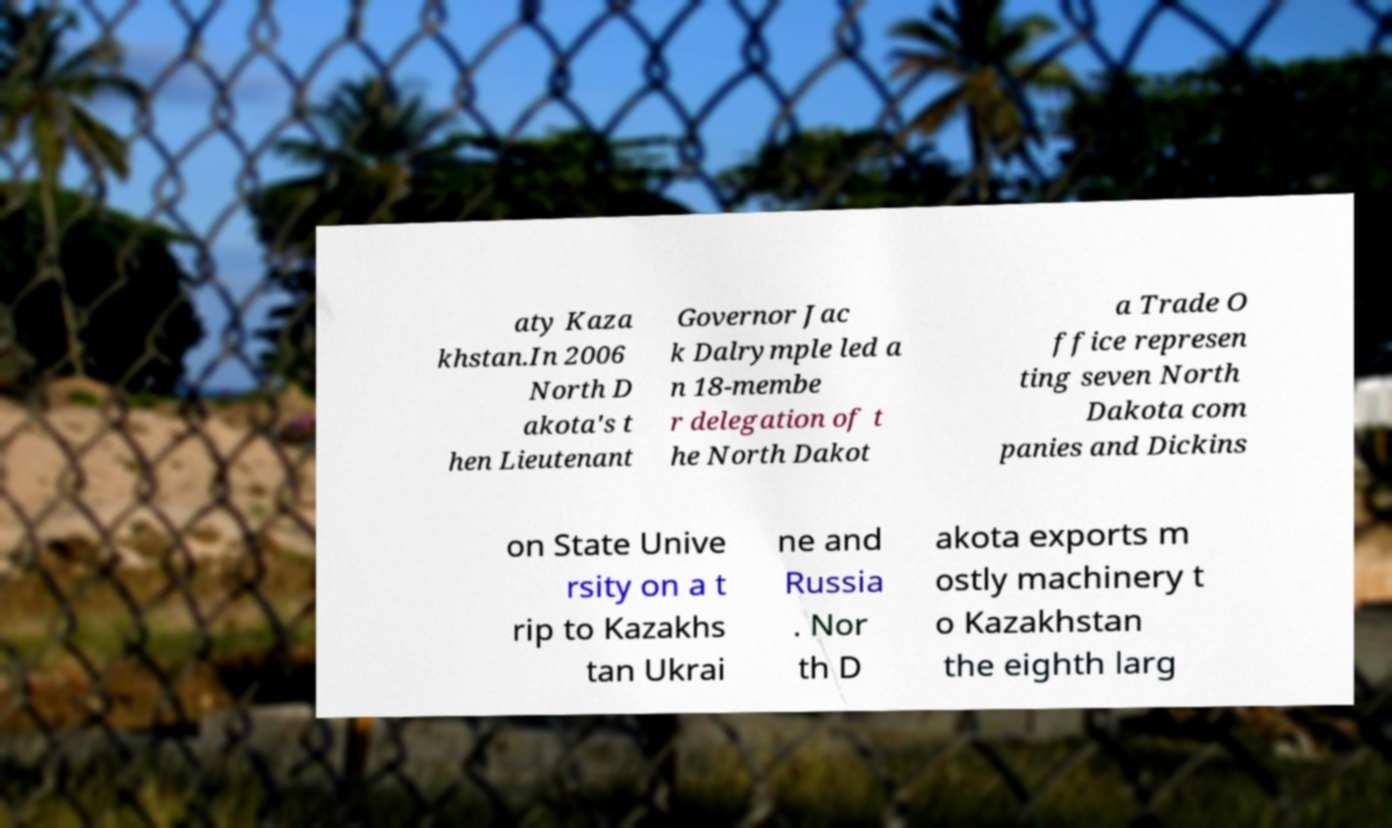What messages or text are displayed in this image? I need them in a readable, typed format. aty Kaza khstan.In 2006 North D akota's t hen Lieutenant Governor Jac k Dalrymple led a n 18-membe r delegation of t he North Dakot a Trade O ffice represen ting seven North Dakota com panies and Dickins on State Unive rsity on a t rip to Kazakhs tan Ukrai ne and Russia . Nor th D akota exports m ostly machinery t o Kazakhstan the eighth larg 